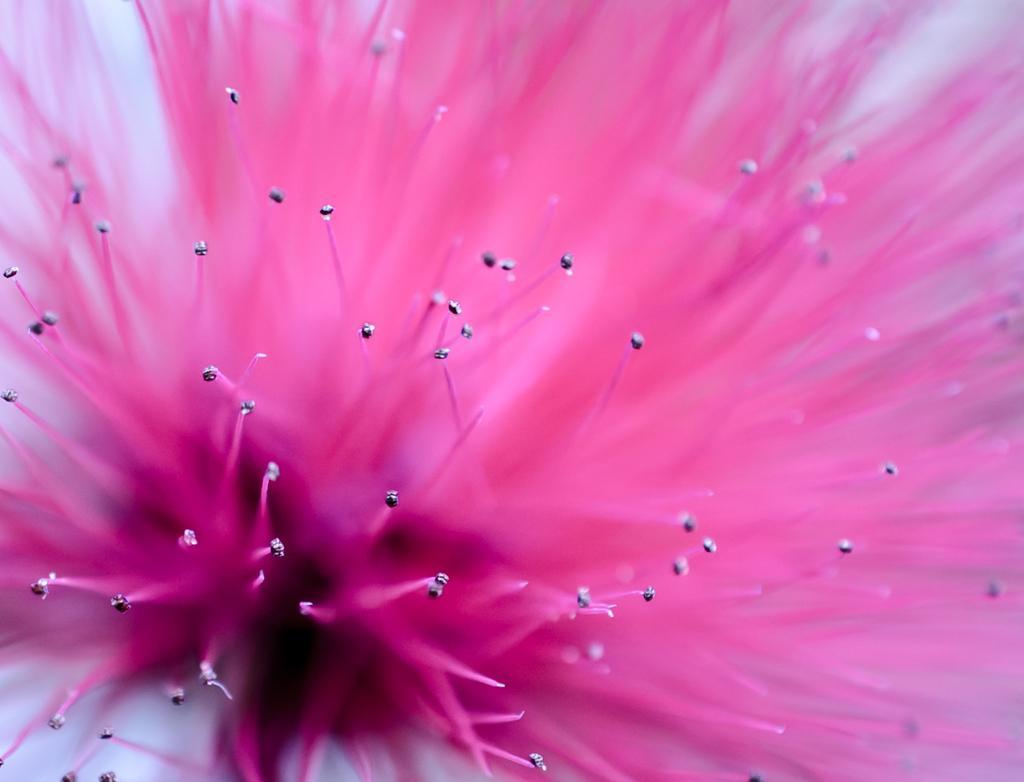Describe this image in one or two sentences. In this image there is a pink flower truncated. 